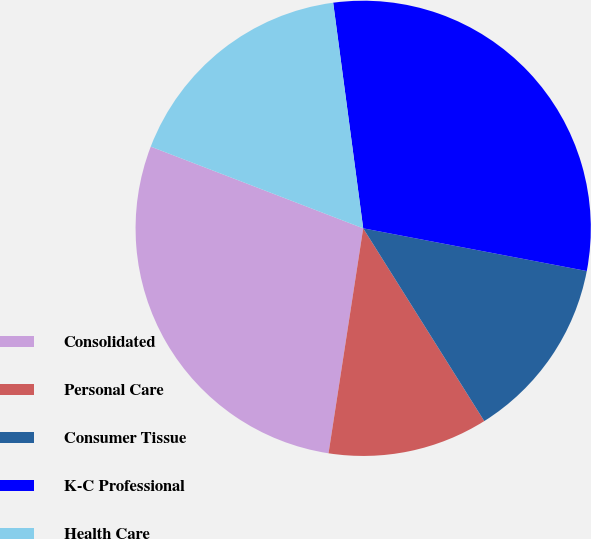Convert chart to OTSL. <chart><loc_0><loc_0><loc_500><loc_500><pie_chart><fcel>Consolidated<fcel>Personal Care<fcel>Consumer Tissue<fcel>K-C Professional<fcel>Health Care<nl><fcel>28.41%<fcel>11.36%<fcel>13.07%<fcel>30.11%<fcel>17.05%<nl></chart> 